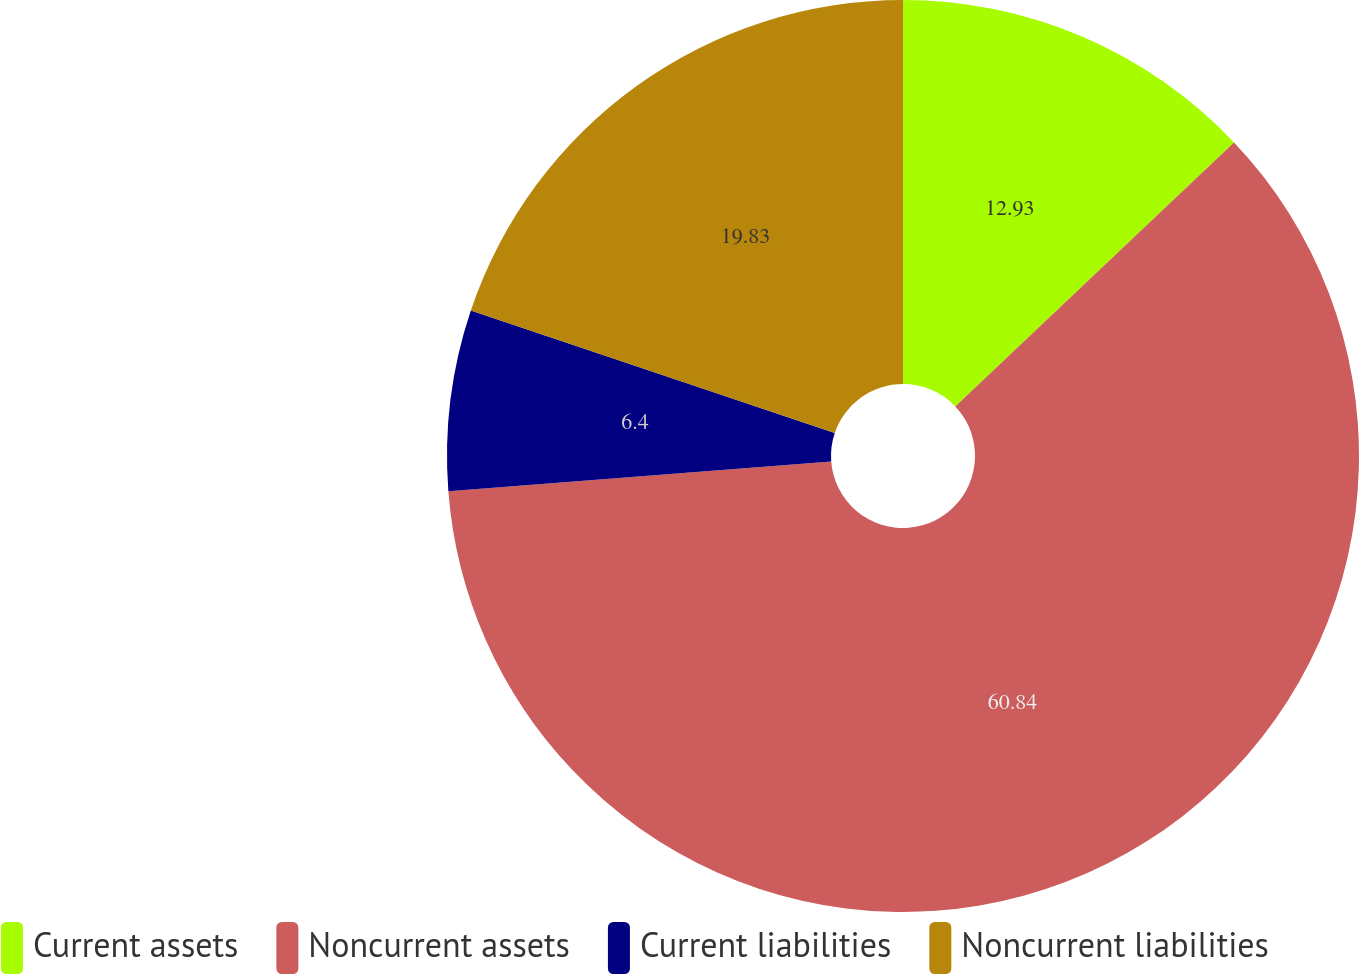Convert chart to OTSL. <chart><loc_0><loc_0><loc_500><loc_500><pie_chart><fcel>Current assets<fcel>Noncurrent assets<fcel>Current liabilities<fcel>Noncurrent liabilities<nl><fcel>12.93%<fcel>60.84%<fcel>6.4%<fcel>19.83%<nl></chart> 